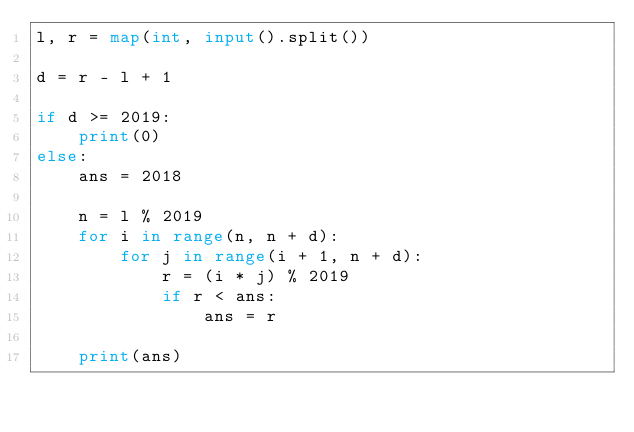<code> <loc_0><loc_0><loc_500><loc_500><_Python_>l, r = map(int, input().split())

d = r - l + 1

if d >= 2019:
    print(0)
else:
    ans = 2018

    n = l % 2019
    for i in range(n, n + d):
        for j in range(i + 1, n + d):
            r = (i * j) % 2019
            if r < ans:
                ans = r

    print(ans)
</code> 